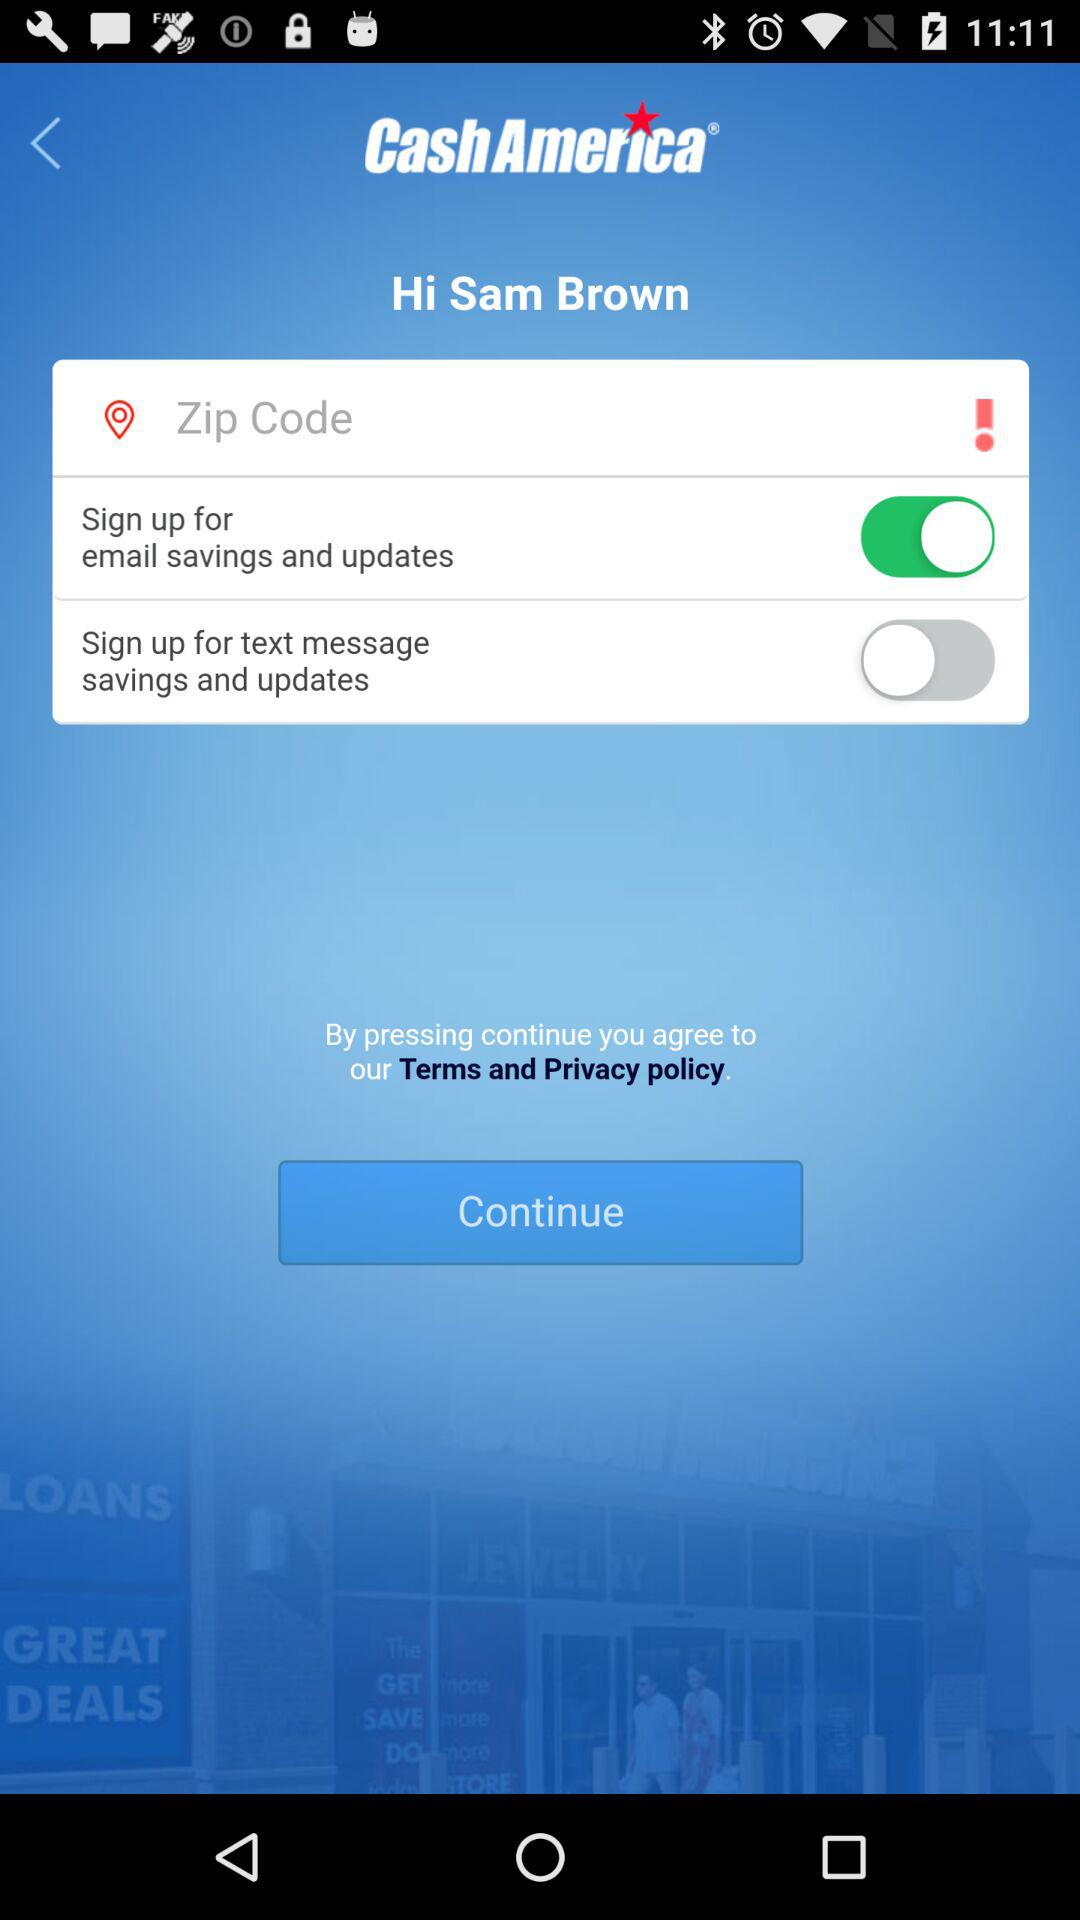What is the application name? The application name is "Cash America". 